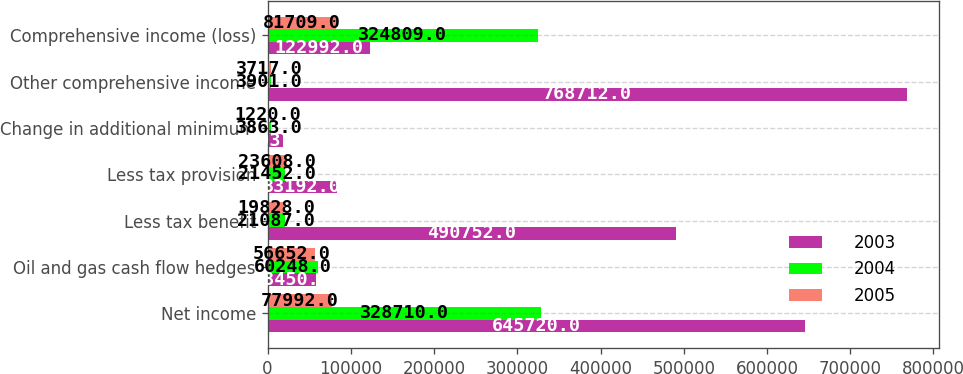Convert chart. <chart><loc_0><loc_0><loc_500><loc_500><stacked_bar_chart><ecel><fcel>Net income<fcel>Oil and gas cash flow hedges<fcel>Less tax benefit<fcel>Less tax provision<fcel>Change in additional minimum<fcel>Other comprehensive income<fcel>Comprehensive income (loss)<nl><fcel>2003<fcel>645720<fcel>58450<fcel>490752<fcel>83192<fcel>18937<fcel>768712<fcel>122992<nl><fcel>2004<fcel>328710<fcel>60248<fcel>21087<fcel>21452<fcel>3863<fcel>3901<fcel>324809<nl><fcel>2005<fcel>77992<fcel>56652<fcel>19828<fcel>23608<fcel>1220<fcel>3717<fcel>81709<nl></chart> 